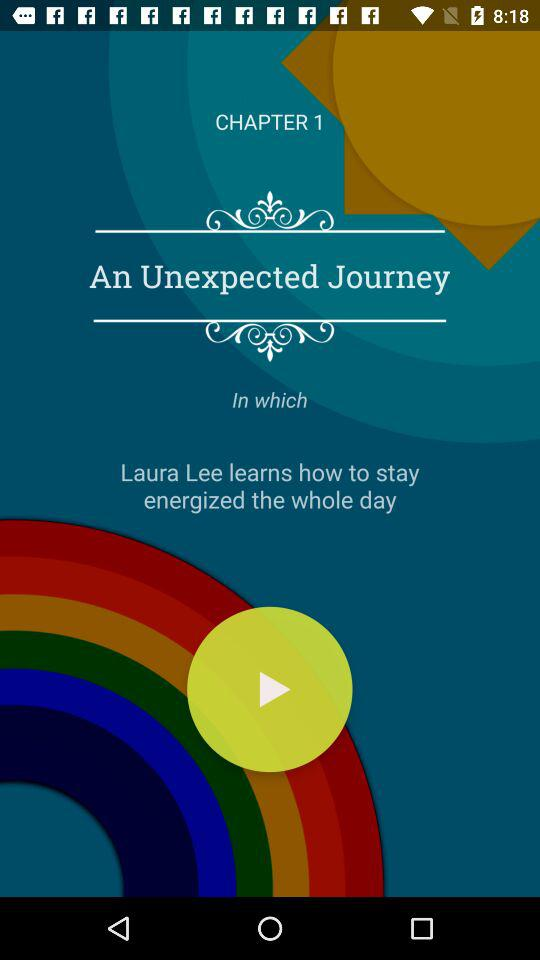What is the mentioned chapter number? The mentioned chapter number is 1. 